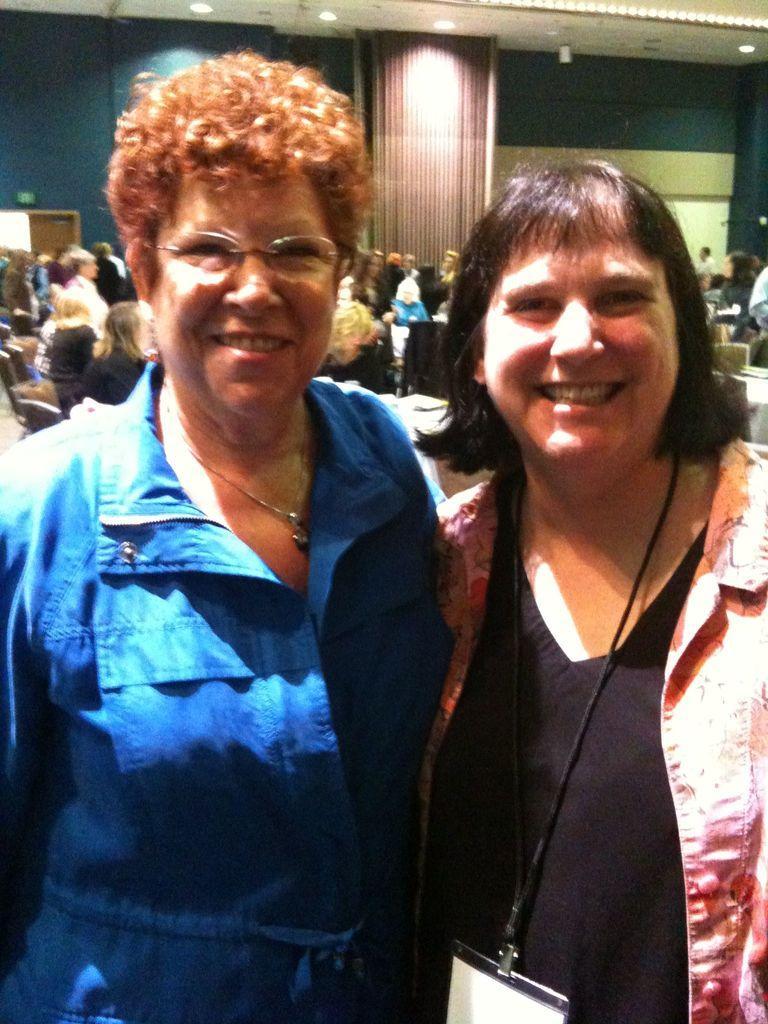How many women are in the middle of the picture? There are two women in the middle of the picture. What expression do the women have? The women are smiling. What can be seen in the background of the image? There are people, a board, a wall, a ceiling, and lights in the background of the image. What color is the robin's tongue in the image? There is no robin present in the image, so it is not possible to determine the color of its tongue. 